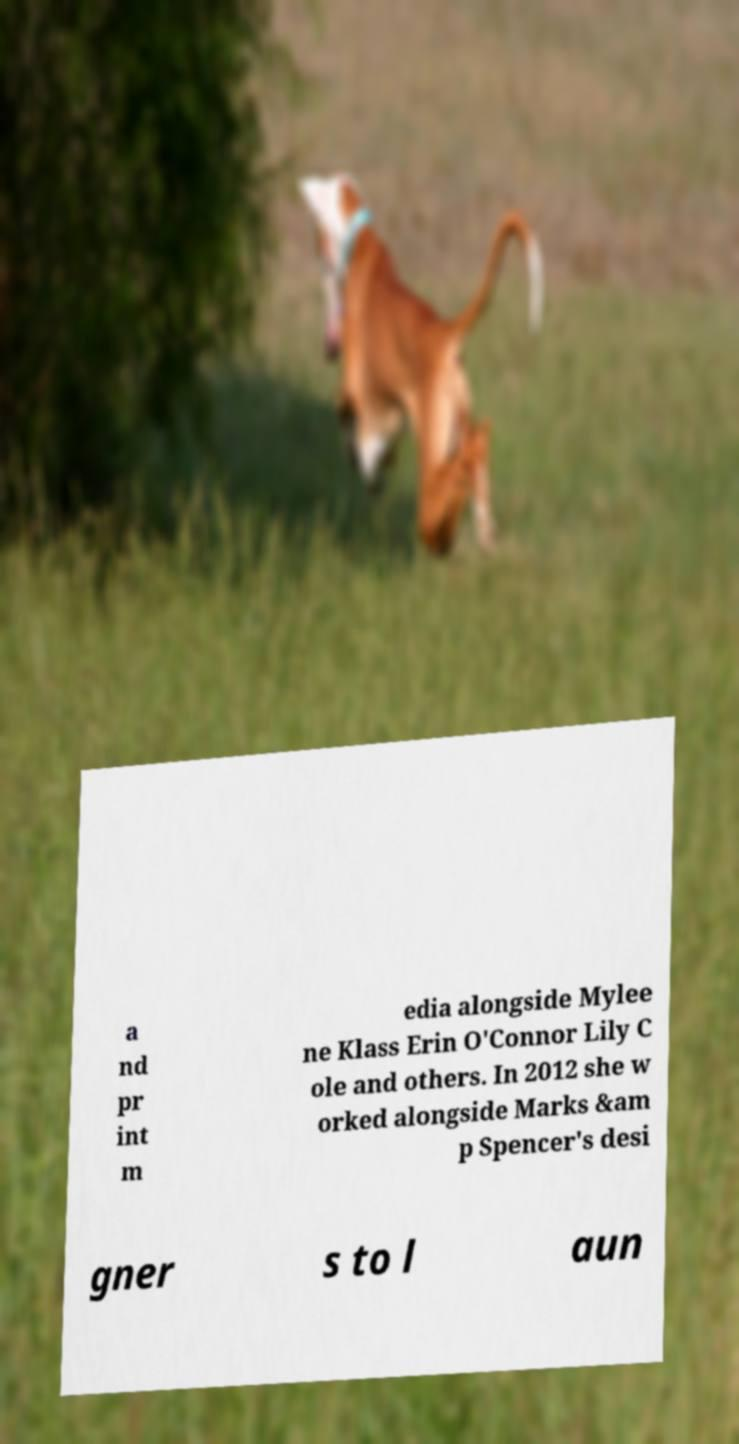I need the written content from this picture converted into text. Can you do that? a nd pr int m edia alongside Mylee ne Klass Erin O'Connor Lily C ole and others. In 2012 she w orked alongside Marks &am p Spencer's desi gner s to l aun 